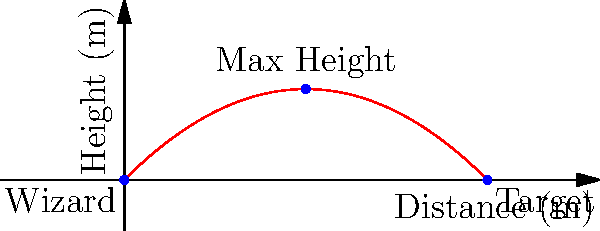In a magical duel, a wizard launches a fireball from their staff with an initial velocity of 50 m/s at a 45-degree angle. Assuming the fireball follows a parabolic trajectory affected by gravity (g = 9.8 m/s²) and neglecting air resistance, what is the maximum height reached by the fireball during its flight? To find the maximum height of the fireball, we can follow these steps:

1. Identify the relevant variables:
   - Initial velocity: $v_0 = 50$ m/s
   - Launch angle: $\theta = 45°$ or $\frac{\pi}{4}$ radians
   - Acceleration due to gravity: $g = 9.8$ m/s²

2. The maximum height occurs when the vertical velocity is zero. We can use the equation:
   $y_{max} = \frac{v_0^2 \sin^2\theta}{2g}$

3. Convert the angle to radians:
   $\sin 45° = \sin \frac{\pi}{4} = \frac{1}{\sqrt{2}} \approx 0.7071$

4. Square the sine value:
   $\sin^2 45° \approx 0.7071^2 \approx 0.5$

5. Substitute the values into the equation:
   $y_{max} = \frac{(50 \text{ m/s})^2 \cdot 0.5}{2 \cdot 9.8 \text{ m/s}^2}$

6. Calculate:
   $y_{max} = \frac{1250 \text{ m}^2}{19.6 \text{ m/s}^2} \approx 63.78$ m

Therefore, the maximum height reached by the fireball is approximately 63.78 meters.
Answer: 63.78 meters 